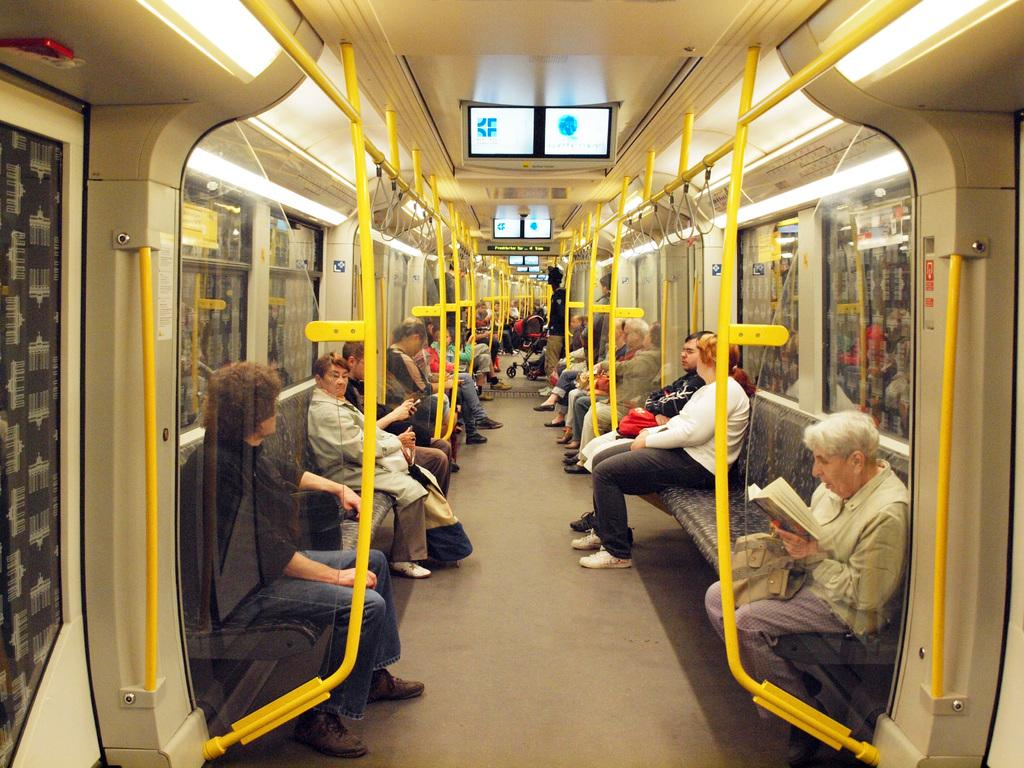Where is the image taken? The image is inside a train. What feature can be found in the train for passengers to hold onto? There are handles in the train. What allows passengers to see the outside scenery while inside the train? There are glass windows in the train. How are people seated in the train? Many people are sitting on seats in the train. What is one lady doing in the train? One lady is holding a book in the train. What type of display can be found in the train? There are screens in the train. What type of wool is being spun by the lady in the train? There is no lady spinning wool in the image; the lady is holding a book. What line is the train currently traveling on? The image does not provide information about the specific line or route the train is traveling on. 